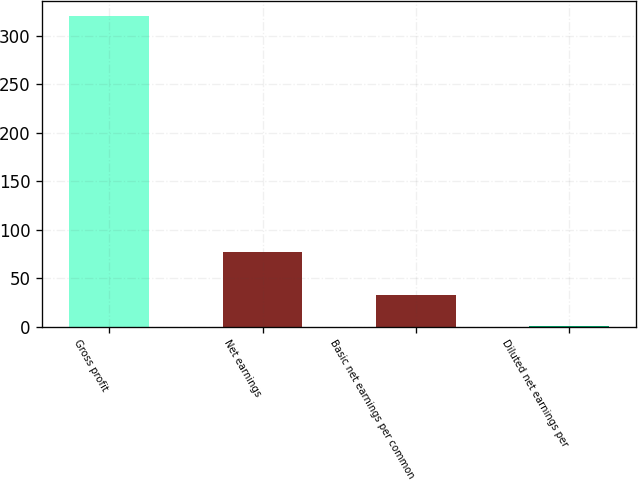<chart> <loc_0><loc_0><loc_500><loc_500><bar_chart><fcel>Gross profit<fcel>Net earnings<fcel>Basic net earnings per common<fcel>Diluted net earnings per<nl><fcel>320.5<fcel>76.5<fcel>32.44<fcel>0.43<nl></chart> 